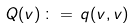Convert formula to latex. <formula><loc_0><loc_0><loc_500><loc_500>Q ( v ) \, \colon = \, q ( v , v )</formula> 